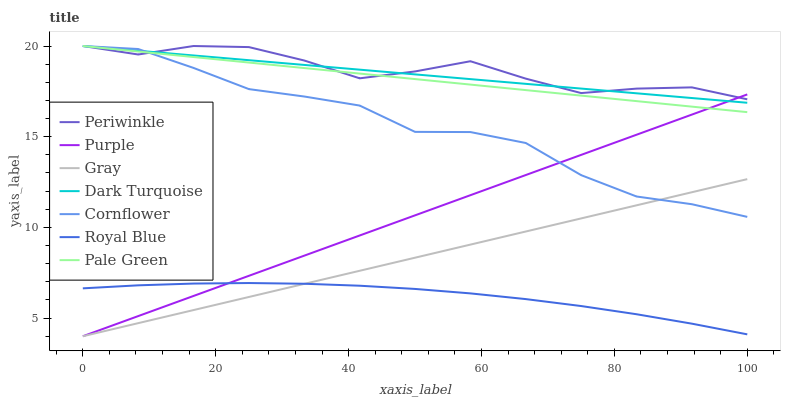Does Cornflower have the minimum area under the curve?
Answer yes or no. No. Does Cornflower have the maximum area under the curve?
Answer yes or no. No. Is Cornflower the smoothest?
Answer yes or no. No. Is Purple the roughest?
Answer yes or no. No. Does Cornflower have the lowest value?
Answer yes or no. No. Does Purple have the highest value?
Answer yes or no. No. Is Royal Blue less than Dark Turquoise?
Answer yes or no. Yes. Is Periwinkle greater than Royal Blue?
Answer yes or no. Yes. Does Royal Blue intersect Dark Turquoise?
Answer yes or no. No. 